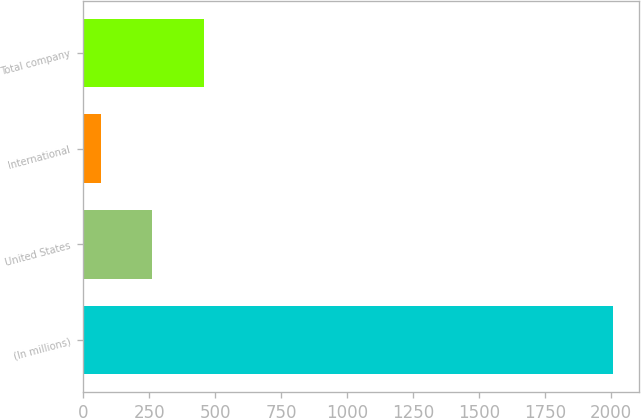Convert chart to OTSL. <chart><loc_0><loc_0><loc_500><loc_500><bar_chart><fcel>(In millions)<fcel>United States<fcel>International<fcel>Total company<nl><fcel>2006<fcel>261.8<fcel>68<fcel>455.6<nl></chart> 